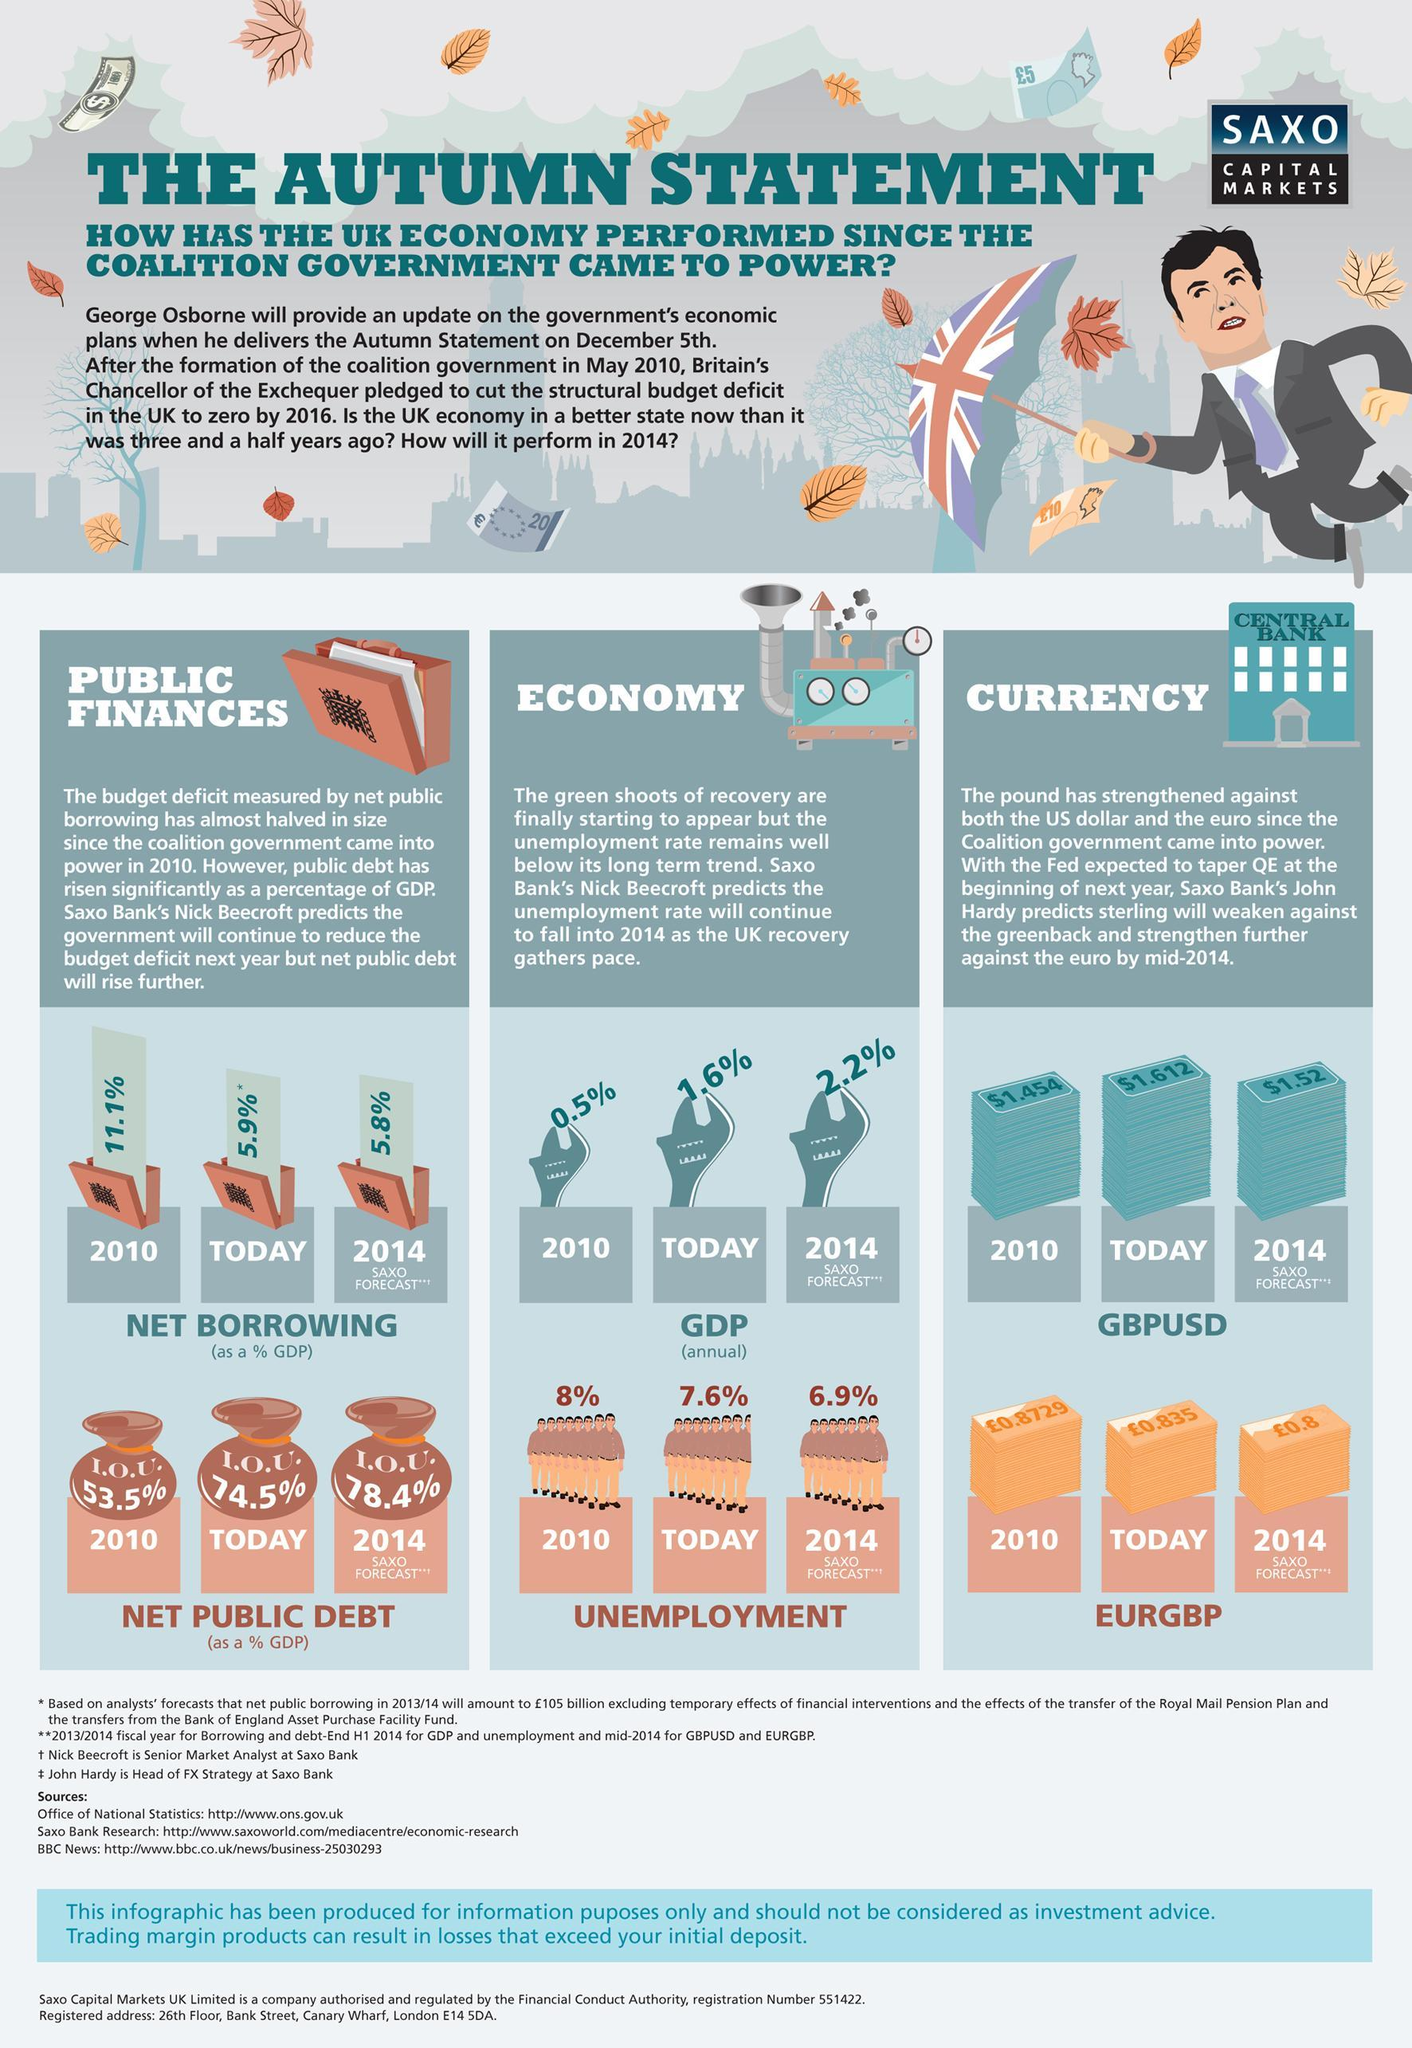What are the 2 main areas covered in Economy
Answer the question with a short phrase. GDP, Unemployment What is written on the building image beside currency Central Bank What are the 2 main points covered in public finances Net Borrowing, Net Public Debt What was the value of pound in 2010 0.8729 What was the value of Dollar in 2010 1.454 Is the net borrowing going to increase or decrease decrease What are the curreny acronyms discussed in currency GBPUSD, EURGBP 